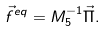<formula> <loc_0><loc_0><loc_500><loc_500>\vec { f } ^ { e q } = M _ { 5 } ^ { - 1 } \vec { \Pi } .</formula> 